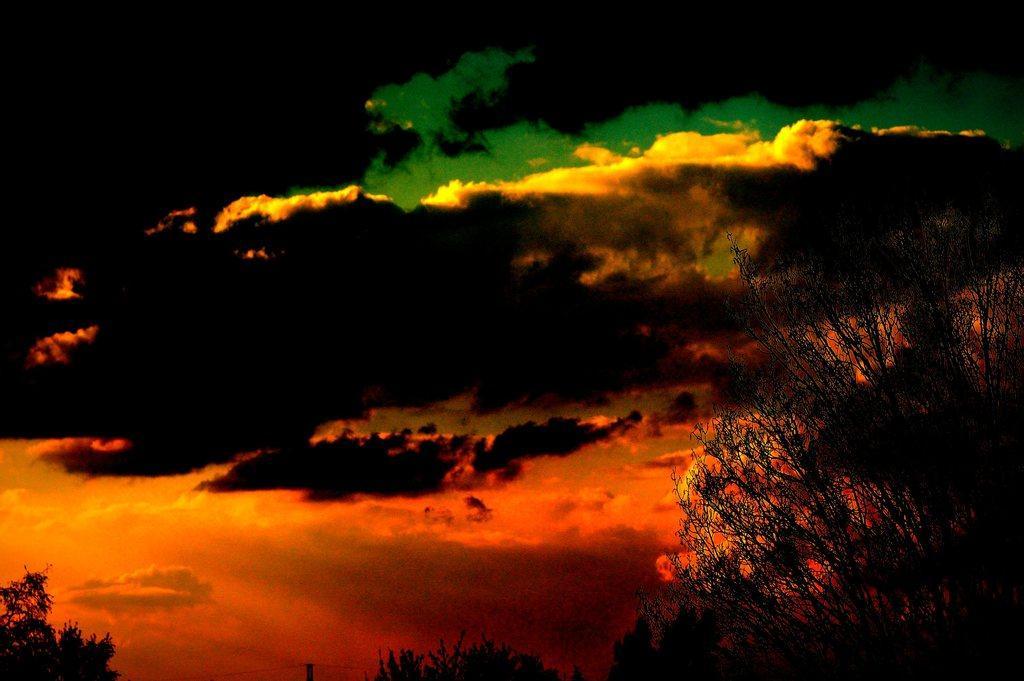Could you give a brief overview of what you see in this image? In the picture we can see some plants and behind it we can see the sky with clouds which are red, yellow, green and black in color. 